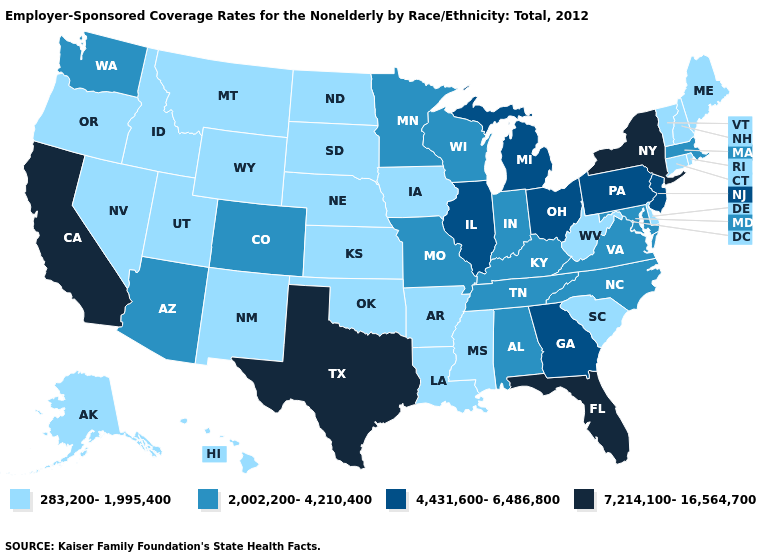Which states have the lowest value in the USA?
Be succinct. Alaska, Arkansas, Connecticut, Delaware, Hawaii, Idaho, Iowa, Kansas, Louisiana, Maine, Mississippi, Montana, Nebraska, Nevada, New Hampshire, New Mexico, North Dakota, Oklahoma, Oregon, Rhode Island, South Carolina, South Dakota, Utah, Vermont, West Virginia, Wyoming. What is the lowest value in the South?
Be succinct. 283,200-1,995,400. Does Oklahoma have the lowest value in the South?
Be succinct. Yes. Among the states that border Massachusetts , does New York have the highest value?
Write a very short answer. Yes. What is the value of West Virginia?
Answer briefly. 283,200-1,995,400. Name the states that have a value in the range 4,431,600-6,486,800?
Concise answer only. Georgia, Illinois, Michigan, New Jersey, Ohio, Pennsylvania. Among the states that border Colorado , which have the lowest value?
Concise answer only. Kansas, Nebraska, New Mexico, Oklahoma, Utah, Wyoming. What is the lowest value in the West?
Answer briefly. 283,200-1,995,400. What is the highest value in the USA?
Quick response, please. 7,214,100-16,564,700. Does the map have missing data?
Give a very brief answer. No. Name the states that have a value in the range 4,431,600-6,486,800?
Write a very short answer. Georgia, Illinois, Michigan, New Jersey, Ohio, Pennsylvania. Does the first symbol in the legend represent the smallest category?
Keep it brief. Yes. What is the value of Arizona?
Answer briefly. 2,002,200-4,210,400. Which states have the highest value in the USA?
Be succinct. California, Florida, New York, Texas. Does Illinois have the highest value in the USA?
Answer briefly. No. 